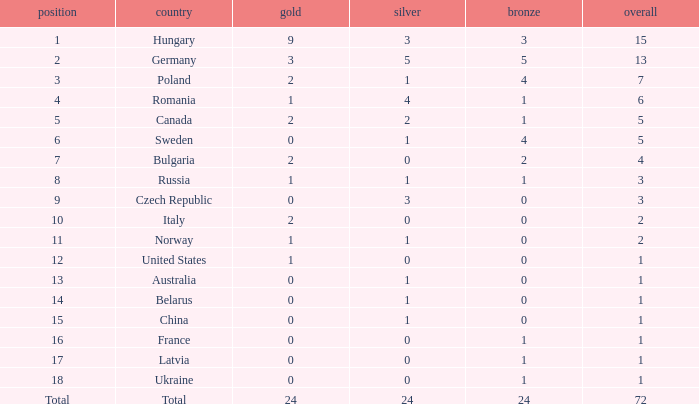What nation has 0 as the silver, 1 as the bronze, with 18 as the rank? Ukraine. 